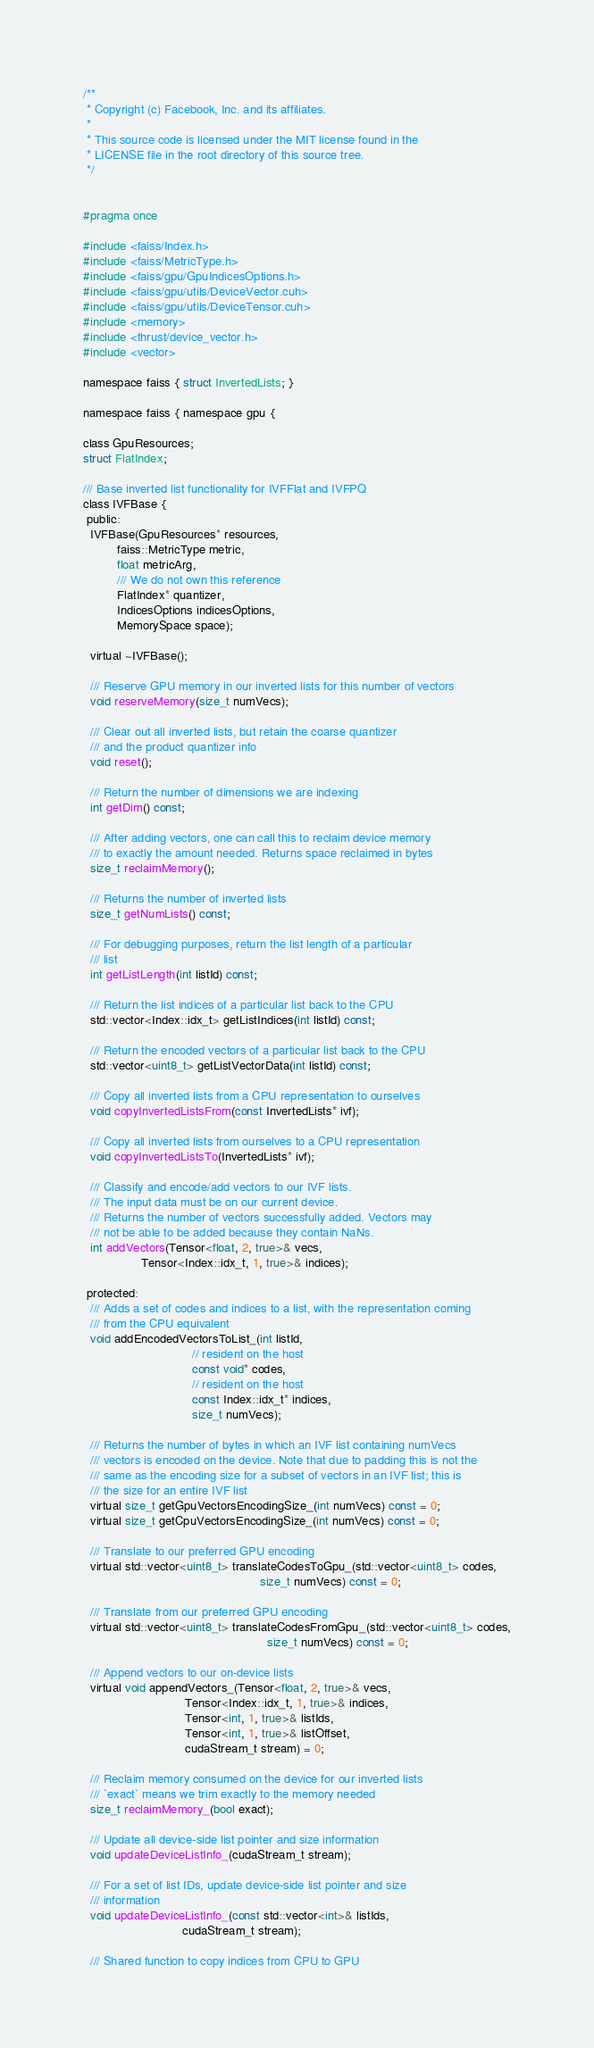<code> <loc_0><loc_0><loc_500><loc_500><_Cuda_>/**
 * Copyright (c) Facebook, Inc. and its affiliates.
 *
 * This source code is licensed under the MIT license found in the
 * LICENSE file in the root directory of this source tree.
 */


#pragma once

#include <faiss/Index.h>
#include <faiss/MetricType.h>
#include <faiss/gpu/GpuIndicesOptions.h>
#include <faiss/gpu/utils/DeviceVector.cuh>
#include <faiss/gpu/utils/DeviceTensor.cuh>
#include <memory>
#include <thrust/device_vector.h>
#include <vector>

namespace faiss { struct InvertedLists; }

namespace faiss { namespace gpu {

class GpuResources;
struct FlatIndex;

/// Base inverted list functionality for IVFFlat and IVFPQ
class IVFBase {
 public:
  IVFBase(GpuResources* resources,
          faiss::MetricType metric,
          float metricArg,
          /// We do not own this reference
          FlatIndex* quantizer,
          IndicesOptions indicesOptions,
          MemorySpace space);

  virtual ~IVFBase();

  /// Reserve GPU memory in our inverted lists for this number of vectors
  void reserveMemory(size_t numVecs);

  /// Clear out all inverted lists, but retain the coarse quantizer
  /// and the product quantizer info
  void reset();

  /// Return the number of dimensions we are indexing
  int getDim() const;

  /// After adding vectors, one can call this to reclaim device memory
  /// to exactly the amount needed. Returns space reclaimed in bytes
  size_t reclaimMemory();

  /// Returns the number of inverted lists
  size_t getNumLists() const;

  /// For debugging purposes, return the list length of a particular
  /// list
  int getListLength(int listId) const;

  /// Return the list indices of a particular list back to the CPU
  std::vector<Index::idx_t> getListIndices(int listId) const;

  /// Return the encoded vectors of a particular list back to the CPU
  std::vector<uint8_t> getListVectorData(int listId) const;

  /// Copy all inverted lists from a CPU representation to ourselves
  void copyInvertedListsFrom(const InvertedLists* ivf);

  /// Copy all inverted lists from ourselves to a CPU representation
  void copyInvertedListsTo(InvertedLists* ivf);

  /// Classify and encode/add vectors to our IVF lists.
  /// The input data must be on our current device.
  /// Returns the number of vectors successfully added. Vectors may
  /// not be able to be added because they contain NaNs.
  int addVectors(Tensor<float, 2, true>& vecs,
                 Tensor<Index::idx_t, 1, true>& indices);

 protected:
  /// Adds a set of codes and indices to a list, with the representation coming
  /// from the CPU equivalent
  void addEncodedVectorsToList_(int listId,
                                // resident on the host
                                const void* codes,
                                // resident on the host
                                const Index::idx_t* indices,
                                size_t numVecs);

  /// Returns the number of bytes in which an IVF list containing numVecs
  /// vectors is encoded on the device. Note that due to padding this is not the
  /// same as the encoding size for a subset of vectors in an IVF list; this is
  /// the size for an entire IVF list
  virtual size_t getGpuVectorsEncodingSize_(int numVecs) const = 0;
  virtual size_t getCpuVectorsEncodingSize_(int numVecs) const = 0;

  /// Translate to our preferred GPU encoding
  virtual std::vector<uint8_t> translateCodesToGpu_(std::vector<uint8_t> codes,
                                                    size_t numVecs) const = 0;

  /// Translate from our preferred GPU encoding
  virtual std::vector<uint8_t> translateCodesFromGpu_(std::vector<uint8_t> codes,
                                                      size_t numVecs) const = 0;

  /// Append vectors to our on-device lists
  virtual void appendVectors_(Tensor<float, 2, true>& vecs,
                              Tensor<Index::idx_t, 1, true>& indices,
                              Tensor<int, 1, true>& listIds,
                              Tensor<int, 1, true>& listOffset,
                              cudaStream_t stream) = 0;

  /// Reclaim memory consumed on the device for our inverted lists
  /// `exact` means we trim exactly to the memory needed
  size_t reclaimMemory_(bool exact);

  /// Update all device-side list pointer and size information
  void updateDeviceListInfo_(cudaStream_t stream);

  /// For a set of list IDs, update device-side list pointer and size
  /// information
  void updateDeviceListInfo_(const std::vector<int>& listIds,
                             cudaStream_t stream);

  /// Shared function to copy indices from CPU to GPU</code> 